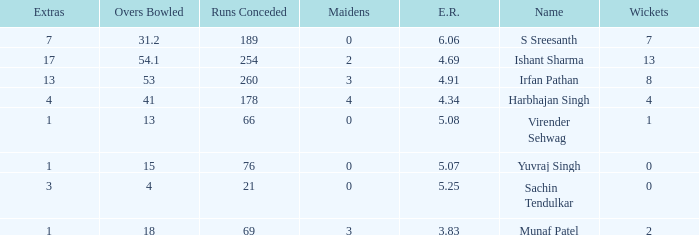Name the maaidens where overs bowled is 13 0.0. 